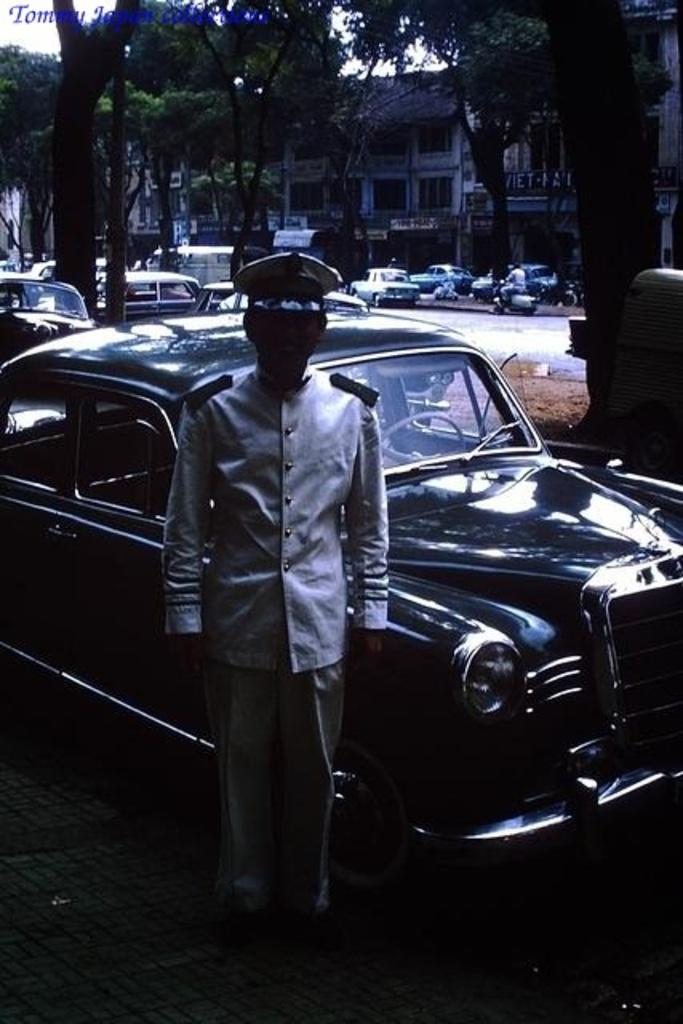What is the main subject of the image? There is a person standing in the image. What else can be seen in the image besides the person? There are cars, trees, a motorcycle, and buildings in the image. What type of bread is being used to cover the trees in the image? There is no bread present in the image, and the trees are not covered by any bread. 